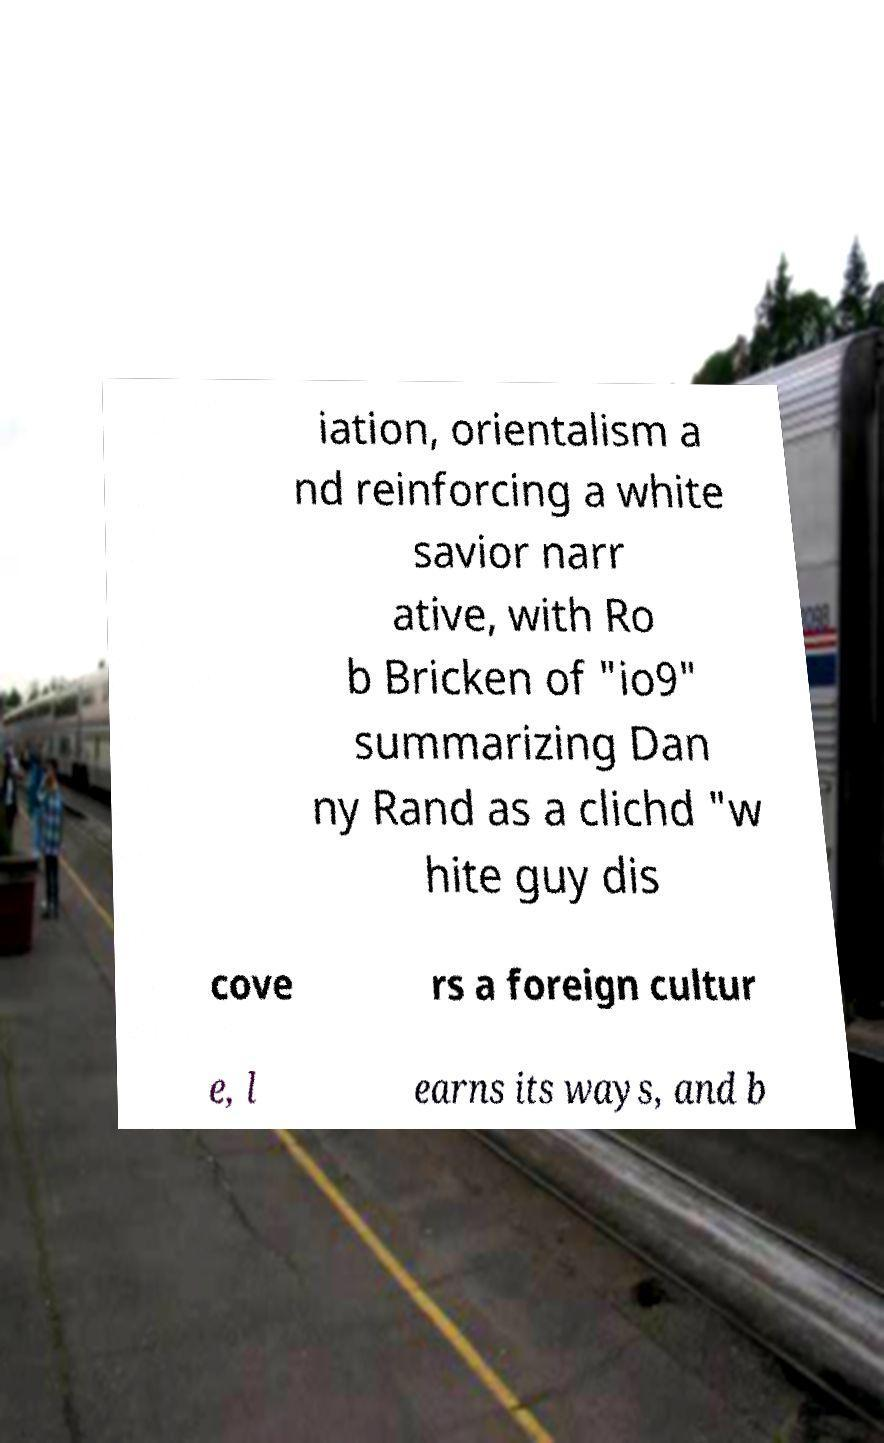Please identify and transcribe the text found in this image. iation, orientalism a nd reinforcing a white savior narr ative, with Ro b Bricken of "io9" summarizing Dan ny Rand as a clichd "w hite guy dis cove rs a foreign cultur e, l earns its ways, and b 